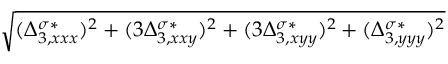<formula> <loc_0><loc_0><loc_500><loc_500>\sqrt { ( \Delta _ { 3 , x x x } ^ { \sigma * } ) ^ { 2 } + ( 3 \Delta _ { 3 , x x y } ^ { \sigma * } ) ^ { 2 } + ( 3 \Delta _ { 3 , x y y } ^ { \sigma * } ) ^ { 2 } + ( \Delta _ { 3 , y y y } ^ { \sigma * } ) ^ { 2 } }</formula> 